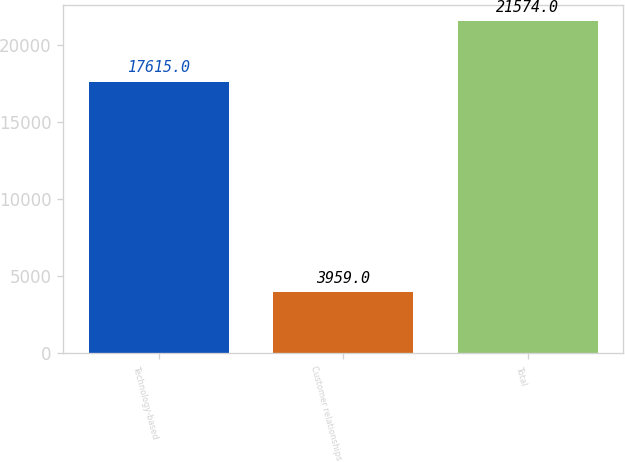Convert chart. <chart><loc_0><loc_0><loc_500><loc_500><bar_chart><fcel>Technology-based<fcel>Customer relationships<fcel>Total<nl><fcel>17615<fcel>3959<fcel>21574<nl></chart> 